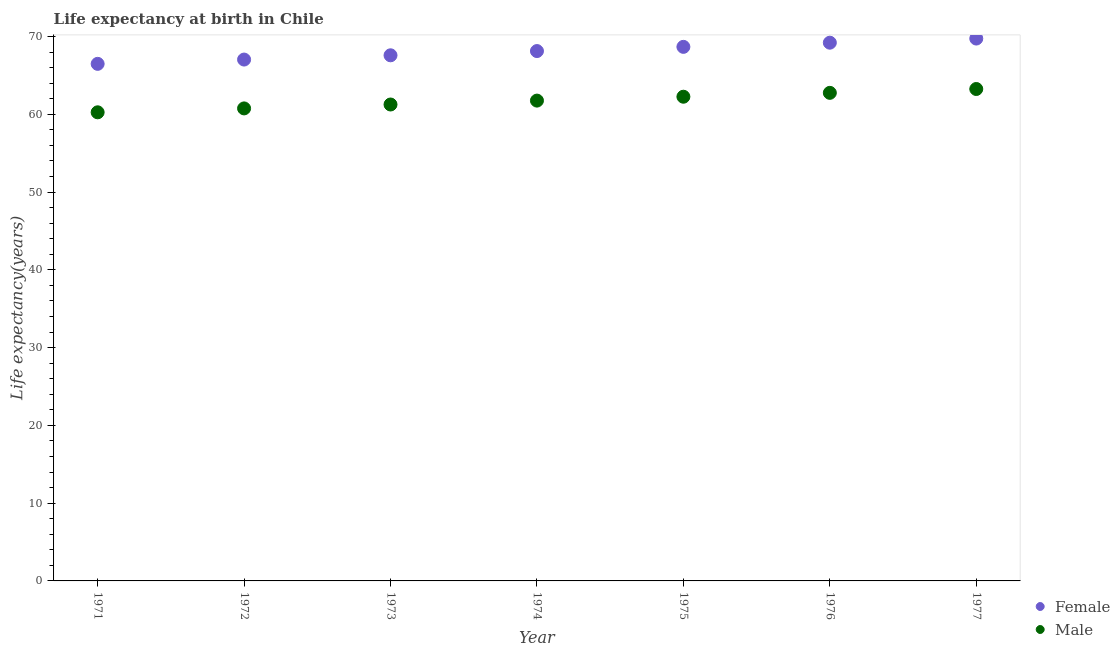How many different coloured dotlines are there?
Keep it short and to the point. 2. What is the life expectancy(female) in 1977?
Your answer should be compact. 69.74. Across all years, what is the maximum life expectancy(female)?
Give a very brief answer. 69.74. Across all years, what is the minimum life expectancy(female)?
Your response must be concise. 66.49. In which year was the life expectancy(male) maximum?
Provide a short and direct response. 1977. In which year was the life expectancy(female) minimum?
Ensure brevity in your answer.  1971. What is the total life expectancy(male) in the graph?
Your answer should be compact. 432.31. What is the difference between the life expectancy(female) in 1973 and that in 1977?
Keep it short and to the point. -2.15. What is the difference between the life expectancy(female) in 1972 and the life expectancy(male) in 1976?
Provide a short and direct response. 4.28. What is the average life expectancy(male) per year?
Make the answer very short. 61.76. In the year 1972, what is the difference between the life expectancy(female) and life expectancy(male)?
Your response must be concise. 6.28. What is the ratio of the life expectancy(female) in 1972 to that in 1974?
Keep it short and to the point. 0.98. Is the life expectancy(male) in 1975 less than that in 1977?
Your answer should be very brief. Yes. Is the difference between the life expectancy(female) in 1972 and 1974 greater than the difference between the life expectancy(male) in 1972 and 1974?
Offer a very short reply. No. What is the difference between the highest and the second highest life expectancy(female)?
Your response must be concise. 0.53. What is the difference between the highest and the lowest life expectancy(female)?
Keep it short and to the point. 3.25. Is the life expectancy(female) strictly greater than the life expectancy(male) over the years?
Offer a terse response. Yes. Is the life expectancy(male) strictly less than the life expectancy(female) over the years?
Give a very brief answer. Yes. How many dotlines are there?
Keep it short and to the point. 2. Are the values on the major ticks of Y-axis written in scientific E-notation?
Give a very brief answer. No. Does the graph contain grids?
Give a very brief answer. No. How many legend labels are there?
Provide a short and direct response. 2. How are the legend labels stacked?
Provide a short and direct response. Vertical. What is the title of the graph?
Your response must be concise. Life expectancy at birth in Chile. Does "Private funds" appear as one of the legend labels in the graph?
Give a very brief answer. No. What is the label or title of the X-axis?
Your answer should be very brief. Year. What is the label or title of the Y-axis?
Provide a short and direct response. Life expectancy(years). What is the Life expectancy(years) of Female in 1971?
Keep it short and to the point. 66.49. What is the Life expectancy(years) in Male in 1971?
Provide a succinct answer. 60.26. What is the Life expectancy(years) in Female in 1972?
Offer a terse response. 67.04. What is the Life expectancy(years) in Male in 1972?
Your answer should be very brief. 60.76. What is the Life expectancy(years) in Female in 1973?
Your response must be concise. 67.59. What is the Life expectancy(years) in Male in 1973?
Your response must be concise. 61.26. What is the Life expectancy(years) of Female in 1974?
Provide a succinct answer. 68.13. What is the Life expectancy(years) of Male in 1974?
Keep it short and to the point. 61.76. What is the Life expectancy(years) in Female in 1975?
Give a very brief answer. 68.67. What is the Life expectancy(years) of Male in 1975?
Provide a short and direct response. 62.26. What is the Life expectancy(years) in Female in 1976?
Provide a short and direct response. 69.21. What is the Life expectancy(years) in Male in 1976?
Ensure brevity in your answer.  62.76. What is the Life expectancy(years) in Female in 1977?
Provide a succinct answer. 69.74. What is the Life expectancy(years) in Male in 1977?
Offer a terse response. 63.25. Across all years, what is the maximum Life expectancy(years) of Female?
Make the answer very short. 69.74. Across all years, what is the maximum Life expectancy(years) in Male?
Your answer should be compact. 63.25. Across all years, what is the minimum Life expectancy(years) in Female?
Give a very brief answer. 66.49. Across all years, what is the minimum Life expectancy(years) of Male?
Offer a very short reply. 60.26. What is the total Life expectancy(years) of Female in the graph?
Make the answer very short. 476.87. What is the total Life expectancy(years) of Male in the graph?
Provide a succinct answer. 432.31. What is the difference between the Life expectancy(years) in Female in 1971 and that in 1972?
Your response must be concise. -0.55. What is the difference between the Life expectancy(years) in Male in 1971 and that in 1972?
Your answer should be compact. -0.5. What is the difference between the Life expectancy(years) of Male in 1971 and that in 1973?
Your response must be concise. -1. What is the difference between the Life expectancy(years) in Female in 1971 and that in 1974?
Ensure brevity in your answer.  -1.65. What is the difference between the Life expectancy(years) of Male in 1971 and that in 1974?
Your answer should be compact. -1.5. What is the difference between the Life expectancy(years) of Female in 1971 and that in 1975?
Provide a succinct answer. -2.19. What is the difference between the Life expectancy(years) of Male in 1971 and that in 1975?
Your answer should be compact. -2. What is the difference between the Life expectancy(years) in Female in 1971 and that in 1976?
Your answer should be very brief. -2.72. What is the difference between the Life expectancy(years) in Male in 1971 and that in 1976?
Your answer should be very brief. -2.5. What is the difference between the Life expectancy(years) of Female in 1971 and that in 1977?
Offer a very short reply. -3.25. What is the difference between the Life expectancy(years) in Male in 1971 and that in 1977?
Give a very brief answer. -3. What is the difference between the Life expectancy(years) in Female in 1972 and that in 1973?
Keep it short and to the point. -0.55. What is the difference between the Life expectancy(years) of Male in 1972 and that in 1973?
Your response must be concise. -0.5. What is the difference between the Life expectancy(years) in Female in 1972 and that in 1974?
Keep it short and to the point. -1.09. What is the difference between the Life expectancy(years) in Male in 1972 and that in 1974?
Your answer should be very brief. -1. What is the difference between the Life expectancy(years) in Female in 1972 and that in 1975?
Offer a very short reply. -1.63. What is the difference between the Life expectancy(years) in Male in 1972 and that in 1975?
Your response must be concise. -1.5. What is the difference between the Life expectancy(years) of Female in 1972 and that in 1976?
Your response must be concise. -2.17. What is the difference between the Life expectancy(years) of Female in 1972 and that in 1977?
Give a very brief answer. -2.7. What is the difference between the Life expectancy(years) in Male in 1972 and that in 1977?
Give a very brief answer. -2.5. What is the difference between the Life expectancy(years) in Female in 1973 and that in 1974?
Offer a very short reply. -0.55. What is the difference between the Life expectancy(years) in Male in 1973 and that in 1974?
Your answer should be compact. -0.5. What is the difference between the Life expectancy(years) of Female in 1973 and that in 1975?
Your answer should be very brief. -1.08. What is the difference between the Life expectancy(years) in Female in 1973 and that in 1976?
Provide a short and direct response. -1.62. What is the difference between the Life expectancy(years) in Male in 1973 and that in 1976?
Provide a short and direct response. -1.5. What is the difference between the Life expectancy(years) in Female in 1973 and that in 1977?
Your answer should be compact. -2.15. What is the difference between the Life expectancy(years) of Male in 1973 and that in 1977?
Your answer should be very brief. -1.99. What is the difference between the Life expectancy(years) of Female in 1974 and that in 1975?
Make the answer very short. -0.54. What is the difference between the Life expectancy(years) of Male in 1974 and that in 1975?
Your response must be concise. -0.5. What is the difference between the Life expectancy(years) in Female in 1974 and that in 1976?
Offer a terse response. -1.08. What is the difference between the Life expectancy(years) of Male in 1974 and that in 1976?
Your response must be concise. -1. What is the difference between the Life expectancy(years) of Female in 1974 and that in 1977?
Offer a terse response. -1.61. What is the difference between the Life expectancy(years) in Male in 1974 and that in 1977?
Make the answer very short. -1.49. What is the difference between the Life expectancy(years) in Female in 1975 and that in 1976?
Your answer should be compact. -0.54. What is the difference between the Life expectancy(years) of Male in 1975 and that in 1976?
Keep it short and to the point. -0.5. What is the difference between the Life expectancy(years) of Female in 1975 and that in 1977?
Ensure brevity in your answer.  -1.07. What is the difference between the Life expectancy(years) in Male in 1975 and that in 1977?
Offer a very short reply. -0.99. What is the difference between the Life expectancy(years) of Female in 1976 and that in 1977?
Keep it short and to the point. -0.53. What is the difference between the Life expectancy(years) of Male in 1976 and that in 1977?
Provide a short and direct response. -0.49. What is the difference between the Life expectancy(years) in Female in 1971 and the Life expectancy(years) in Male in 1972?
Provide a succinct answer. 5.73. What is the difference between the Life expectancy(years) of Female in 1971 and the Life expectancy(years) of Male in 1973?
Ensure brevity in your answer.  5.23. What is the difference between the Life expectancy(years) of Female in 1971 and the Life expectancy(years) of Male in 1974?
Your response must be concise. 4.73. What is the difference between the Life expectancy(years) in Female in 1971 and the Life expectancy(years) in Male in 1975?
Ensure brevity in your answer.  4.23. What is the difference between the Life expectancy(years) of Female in 1971 and the Life expectancy(years) of Male in 1976?
Provide a short and direct response. 3.73. What is the difference between the Life expectancy(years) of Female in 1971 and the Life expectancy(years) of Male in 1977?
Your response must be concise. 3.23. What is the difference between the Life expectancy(years) in Female in 1972 and the Life expectancy(years) in Male in 1973?
Offer a very short reply. 5.78. What is the difference between the Life expectancy(years) of Female in 1972 and the Life expectancy(years) of Male in 1974?
Your answer should be compact. 5.28. What is the difference between the Life expectancy(years) in Female in 1972 and the Life expectancy(years) in Male in 1975?
Make the answer very short. 4.78. What is the difference between the Life expectancy(years) in Female in 1972 and the Life expectancy(years) in Male in 1976?
Give a very brief answer. 4.28. What is the difference between the Life expectancy(years) in Female in 1972 and the Life expectancy(years) in Male in 1977?
Give a very brief answer. 3.79. What is the difference between the Life expectancy(years) in Female in 1973 and the Life expectancy(years) in Male in 1974?
Your answer should be compact. 5.83. What is the difference between the Life expectancy(years) in Female in 1973 and the Life expectancy(years) in Male in 1975?
Your answer should be compact. 5.33. What is the difference between the Life expectancy(years) in Female in 1973 and the Life expectancy(years) in Male in 1976?
Ensure brevity in your answer.  4.83. What is the difference between the Life expectancy(years) in Female in 1973 and the Life expectancy(years) in Male in 1977?
Provide a succinct answer. 4.33. What is the difference between the Life expectancy(years) of Female in 1974 and the Life expectancy(years) of Male in 1975?
Provide a succinct answer. 5.87. What is the difference between the Life expectancy(years) in Female in 1974 and the Life expectancy(years) in Male in 1976?
Offer a very short reply. 5.37. What is the difference between the Life expectancy(years) of Female in 1974 and the Life expectancy(years) of Male in 1977?
Your answer should be compact. 4.88. What is the difference between the Life expectancy(years) of Female in 1975 and the Life expectancy(years) of Male in 1976?
Your answer should be compact. 5.91. What is the difference between the Life expectancy(years) in Female in 1975 and the Life expectancy(years) in Male in 1977?
Ensure brevity in your answer.  5.42. What is the difference between the Life expectancy(years) of Female in 1976 and the Life expectancy(years) of Male in 1977?
Make the answer very short. 5.96. What is the average Life expectancy(years) in Female per year?
Provide a short and direct response. 68.12. What is the average Life expectancy(years) in Male per year?
Offer a terse response. 61.76. In the year 1971, what is the difference between the Life expectancy(years) of Female and Life expectancy(years) of Male?
Offer a terse response. 6.23. In the year 1972, what is the difference between the Life expectancy(years) in Female and Life expectancy(years) in Male?
Make the answer very short. 6.28. In the year 1973, what is the difference between the Life expectancy(years) in Female and Life expectancy(years) in Male?
Offer a very short reply. 6.33. In the year 1974, what is the difference between the Life expectancy(years) in Female and Life expectancy(years) in Male?
Your answer should be very brief. 6.37. In the year 1975, what is the difference between the Life expectancy(years) of Female and Life expectancy(years) of Male?
Make the answer very short. 6.41. In the year 1976, what is the difference between the Life expectancy(years) of Female and Life expectancy(years) of Male?
Keep it short and to the point. 6.45. In the year 1977, what is the difference between the Life expectancy(years) in Female and Life expectancy(years) in Male?
Your answer should be very brief. 6.49. What is the ratio of the Life expectancy(years) in Female in 1971 to that in 1972?
Make the answer very short. 0.99. What is the ratio of the Life expectancy(years) of Female in 1971 to that in 1973?
Provide a short and direct response. 0.98. What is the ratio of the Life expectancy(years) of Male in 1971 to that in 1973?
Make the answer very short. 0.98. What is the ratio of the Life expectancy(years) of Female in 1971 to that in 1974?
Keep it short and to the point. 0.98. What is the ratio of the Life expectancy(years) in Male in 1971 to that in 1974?
Offer a very short reply. 0.98. What is the ratio of the Life expectancy(years) of Female in 1971 to that in 1975?
Give a very brief answer. 0.97. What is the ratio of the Life expectancy(years) in Male in 1971 to that in 1975?
Provide a short and direct response. 0.97. What is the ratio of the Life expectancy(years) in Female in 1971 to that in 1976?
Make the answer very short. 0.96. What is the ratio of the Life expectancy(years) in Male in 1971 to that in 1976?
Provide a succinct answer. 0.96. What is the ratio of the Life expectancy(years) of Female in 1971 to that in 1977?
Provide a succinct answer. 0.95. What is the ratio of the Life expectancy(years) of Male in 1971 to that in 1977?
Your answer should be very brief. 0.95. What is the ratio of the Life expectancy(years) in Female in 1972 to that in 1973?
Offer a very short reply. 0.99. What is the ratio of the Life expectancy(years) of Male in 1972 to that in 1973?
Provide a succinct answer. 0.99. What is the ratio of the Life expectancy(years) of Male in 1972 to that in 1974?
Offer a terse response. 0.98. What is the ratio of the Life expectancy(years) in Female in 1972 to that in 1975?
Provide a short and direct response. 0.98. What is the ratio of the Life expectancy(years) in Male in 1972 to that in 1975?
Your answer should be compact. 0.98. What is the ratio of the Life expectancy(years) of Female in 1972 to that in 1976?
Give a very brief answer. 0.97. What is the ratio of the Life expectancy(years) in Male in 1972 to that in 1976?
Your answer should be very brief. 0.97. What is the ratio of the Life expectancy(years) of Female in 1972 to that in 1977?
Provide a succinct answer. 0.96. What is the ratio of the Life expectancy(years) of Male in 1972 to that in 1977?
Ensure brevity in your answer.  0.96. What is the ratio of the Life expectancy(years) of Female in 1973 to that in 1974?
Provide a short and direct response. 0.99. What is the ratio of the Life expectancy(years) in Female in 1973 to that in 1975?
Ensure brevity in your answer.  0.98. What is the ratio of the Life expectancy(years) of Male in 1973 to that in 1975?
Offer a terse response. 0.98. What is the ratio of the Life expectancy(years) of Female in 1973 to that in 1976?
Keep it short and to the point. 0.98. What is the ratio of the Life expectancy(years) of Male in 1973 to that in 1976?
Your answer should be compact. 0.98. What is the ratio of the Life expectancy(years) of Female in 1973 to that in 1977?
Your answer should be compact. 0.97. What is the ratio of the Life expectancy(years) of Male in 1973 to that in 1977?
Offer a terse response. 0.97. What is the ratio of the Life expectancy(years) in Male in 1974 to that in 1975?
Offer a terse response. 0.99. What is the ratio of the Life expectancy(years) of Female in 1974 to that in 1976?
Keep it short and to the point. 0.98. What is the ratio of the Life expectancy(years) in Male in 1974 to that in 1976?
Provide a short and direct response. 0.98. What is the ratio of the Life expectancy(years) of Female in 1974 to that in 1977?
Offer a very short reply. 0.98. What is the ratio of the Life expectancy(years) of Male in 1974 to that in 1977?
Provide a short and direct response. 0.98. What is the ratio of the Life expectancy(years) in Female in 1975 to that in 1977?
Ensure brevity in your answer.  0.98. What is the ratio of the Life expectancy(years) of Male in 1975 to that in 1977?
Offer a very short reply. 0.98. What is the ratio of the Life expectancy(years) in Female in 1976 to that in 1977?
Give a very brief answer. 0.99. What is the ratio of the Life expectancy(years) in Male in 1976 to that in 1977?
Provide a succinct answer. 0.99. What is the difference between the highest and the second highest Life expectancy(years) in Female?
Offer a terse response. 0.53. What is the difference between the highest and the second highest Life expectancy(years) in Male?
Ensure brevity in your answer.  0.49. What is the difference between the highest and the lowest Life expectancy(years) in Female?
Keep it short and to the point. 3.25. What is the difference between the highest and the lowest Life expectancy(years) in Male?
Keep it short and to the point. 3. 